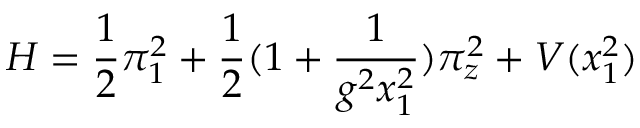Convert formula to latex. <formula><loc_0><loc_0><loc_500><loc_500>H = \frac { 1 } { 2 } \pi _ { 1 } ^ { 2 } + \frac { 1 } { 2 } ( 1 + \frac { 1 } { g ^ { 2 } x _ { 1 } ^ { 2 } } ) \pi _ { z } ^ { 2 } + V ( x _ { 1 } ^ { 2 } )</formula> 